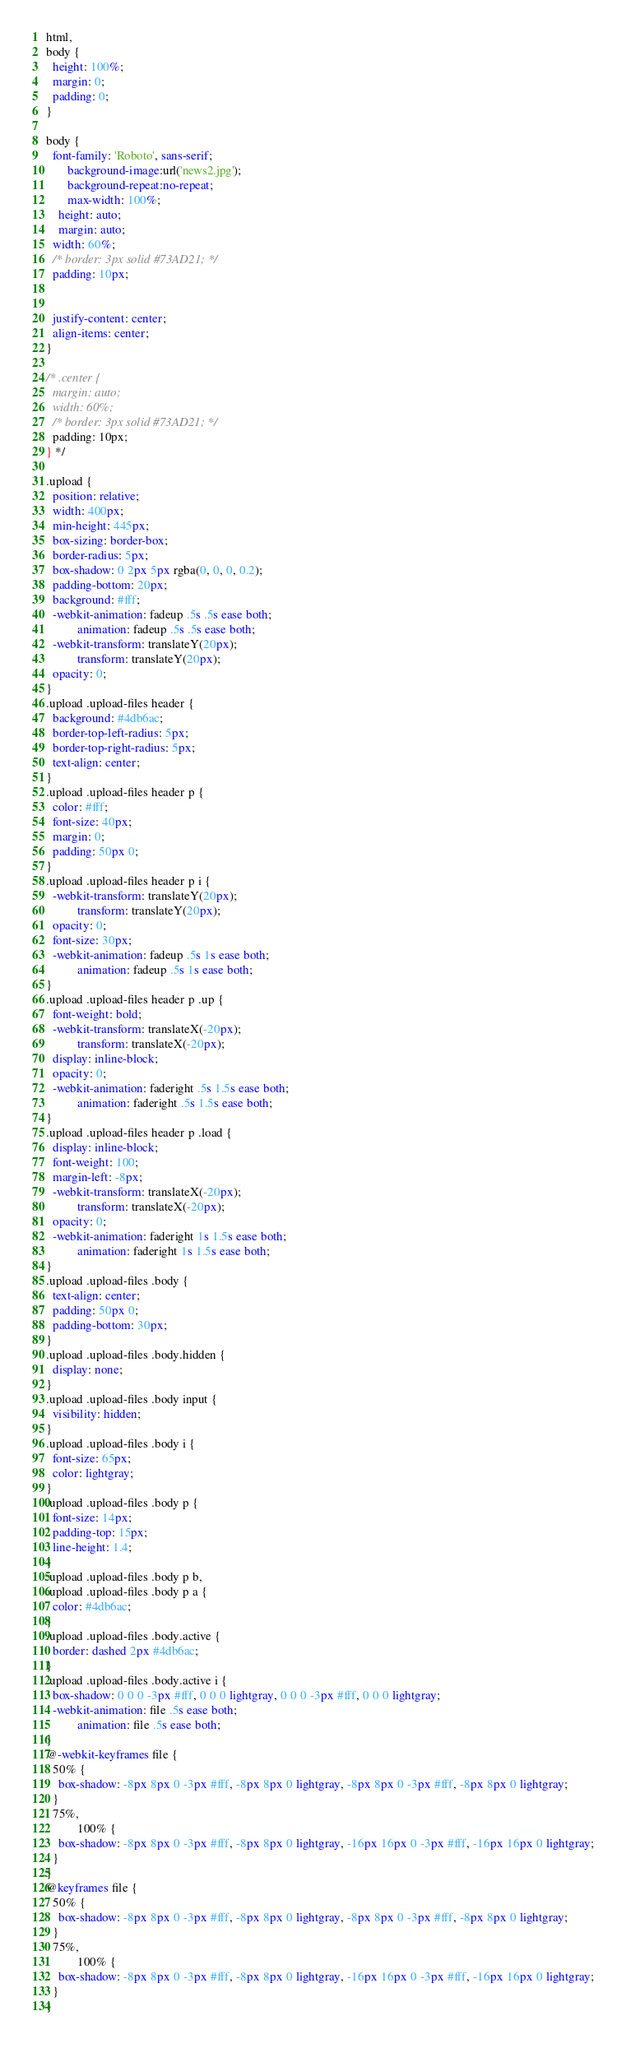Convert code to text. <code><loc_0><loc_0><loc_500><loc_500><_CSS_>html,
body {
  height: 100%;
  margin: 0;
  padding: 0;
}

body {
  font-family: 'Roboto', sans-serif;
       background-image:url('news2.jpg');
	   background-repeat:no-repeat;
	   max-width: 100%;
    height: auto;
    margin: auto;
  width: 60%;
  /* border: 3px solid #73AD21; */
  padding: 10px;

 
  justify-content: center;
  align-items: center;
}

/* .center {
  margin: auto;
  width: 60%;
  /* border: 3px solid #73AD21; */
  padding: 10px;
} */

.upload {
  position: relative;
  width: 400px;
  min-height: 445px;
  box-sizing: border-box;
  border-radius: 5px;
  box-shadow: 0 2px 5px rgba(0, 0, 0, 0.2);
  padding-bottom: 20px;
  background: #fff;
  -webkit-animation: fadeup .5s .5s ease both;
          animation: fadeup .5s .5s ease both;
  -webkit-transform: translateY(20px);
          transform: translateY(20px);
  opacity: 0;
}
.upload .upload-files header {
  background: #4db6ac;
  border-top-left-radius: 5px;
  border-top-right-radius: 5px;
  text-align: center;
}
.upload .upload-files header p {
  color: #fff;
  font-size: 40px;
  margin: 0;
  padding: 50px 0;
}
.upload .upload-files header p i {
  -webkit-transform: translateY(20px);
          transform: translateY(20px);
  opacity: 0;
  font-size: 30px;
  -webkit-animation: fadeup .5s 1s ease both;
          animation: fadeup .5s 1s ease both;
}
.upload .upload-files header p .up {
  font-weight: bold;
  -webkit-transform: translateX(-20px);
          transform: translateX(-20px);
  display: inline-block;
  opacity: 0;
  -webkit-animation: faderight .5s 1.5s ease both;
          animation: faderight .5s 1.5s ease both;
}
.upload .upload-files header p .load {
  display: inline-block;
  font-weight: 100;
  margin-left: -8px;
  -webkit-transform: translateX(-20px);
          transform: translateX(-20px);
  opacity: 0;
  -webkit-animation: faderight 1s 1.5s ease both;
          animation: faderight 1s 1.5s ease both;
}
.upload .upload-files .body {
  text-align: center;
  padding: 50px 0;
  padding-bottom: 30px;
}
.upload .upload-files .body.hidden {
  display: none;
}
.upload .upload-files .body input {
  visibility: hidden;
}
.upload .upload-files .body i {
  font-size: 65px;
  color: lightgray;
}
.upload .upload-files .body p {
  font-size: 14px;
  padding-top: 15px;
  line-height: 1.4;
}
.upload .upload-files .body p b,
.upload .upload-files .body p a {
  color: #4db6ac;
}
.upload .upload-files .body.active {
  border: dashed 2px #4db6ac;
}
.upload .upload-files .body.active i {
  box-shadow: 0 0 0 -3px #fff, 0 0 0 lightgray, 0 0 0 -3px #fff, 0 0 0 lightgray;
  -webkit-animation: file .5s ease both;
          animation: file .5s ease both;
}
@-webkit-keyframes file {
  50% {
    box-shadow: -8px 8px 0 -3px #fff, -8px 8px 0 lightgray, -8px 8px 0 -3px #fff, -8px 8px 0 lightgray;
  }
  75%,
          100% {
    box-shadow: -8px 8px 0 -3px #fff, -8px 8px 0 lightgray, -16px 16px 0 -3px #fff, -16px 16px 0 lightgray;
  }
}
@keyframes file {
  50% {
    box-shadow: -8px 8px 0 -3px #fff, -8px 8px 0 lightgray, -8px 8px 0 -3px #fff, -8px 8px 0 lightgray;
  }
  75%,
          100% {
    box-shadow: -8px 8px 0 -3px #fff, -8px 8px 0 lightgray, -16px 16px 0 -3px #fff, -16px 16px 0 lightgray;
  }
}</code> 